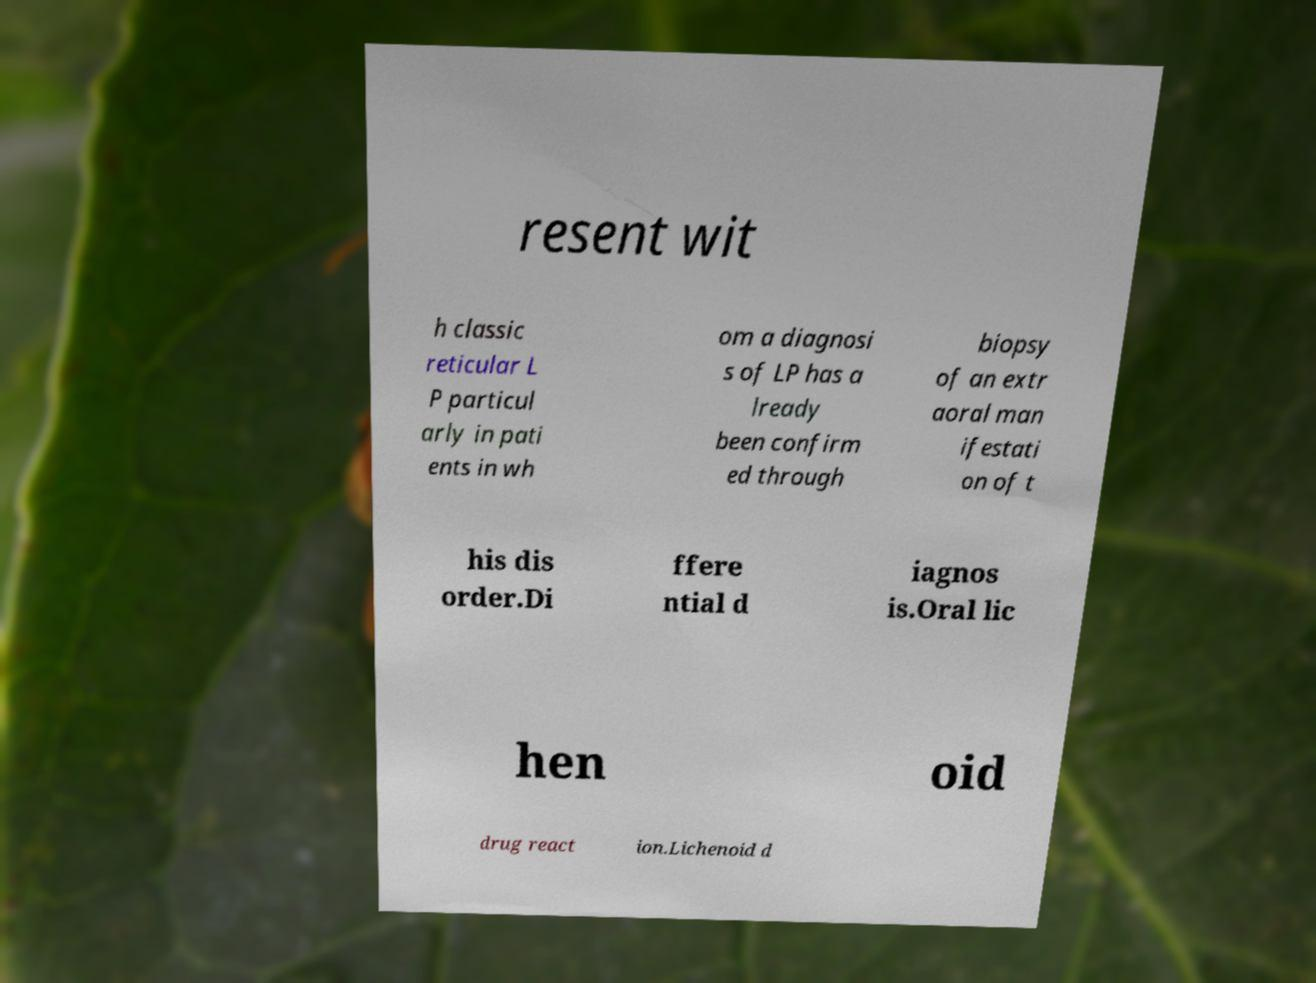Can you accurately transcribe the text from the provided image for me? resent wit h classic reticular L P particul arly in pati ents in wh om a diagnosi s of LP has a lready been confirm ed through biopsy of an extr aoral man ifestati on of t his dis order.Di ffere ntial d iagnos is.Oral lic hen oid drug react ion.Lichenoid d 